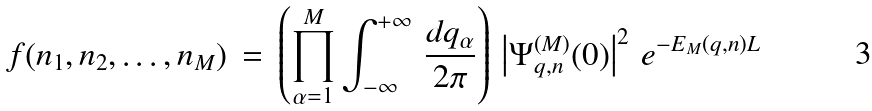Convert formula to latex. <formula><loc_0><loc_0><loc_500><loc_500>f ( n _ { 1 } , n _ { 2 } , \dots , n _ { M } ) \, = \, \left ( \prod _ { \alpha = 1 } ^ { M } \int _ { - \infty } ^ { + \infty } \, \frac { d q _ { \alpha } } { 2 \pi } \right ) \, \left | \Psi _ { q , n } ^ { ( M ) } ( { 0 } ) \right | ^ { 2 } \, e ^ { - E _ { M } ( { q , n } ) L }</formula> 